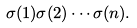Convert formula to latex. <formula><loc_0><loc_0><loc_500><loc_500>\sigma ( 1 ) \sigma ( 2 ) \cdots \sigma ( n ) .</formula> 